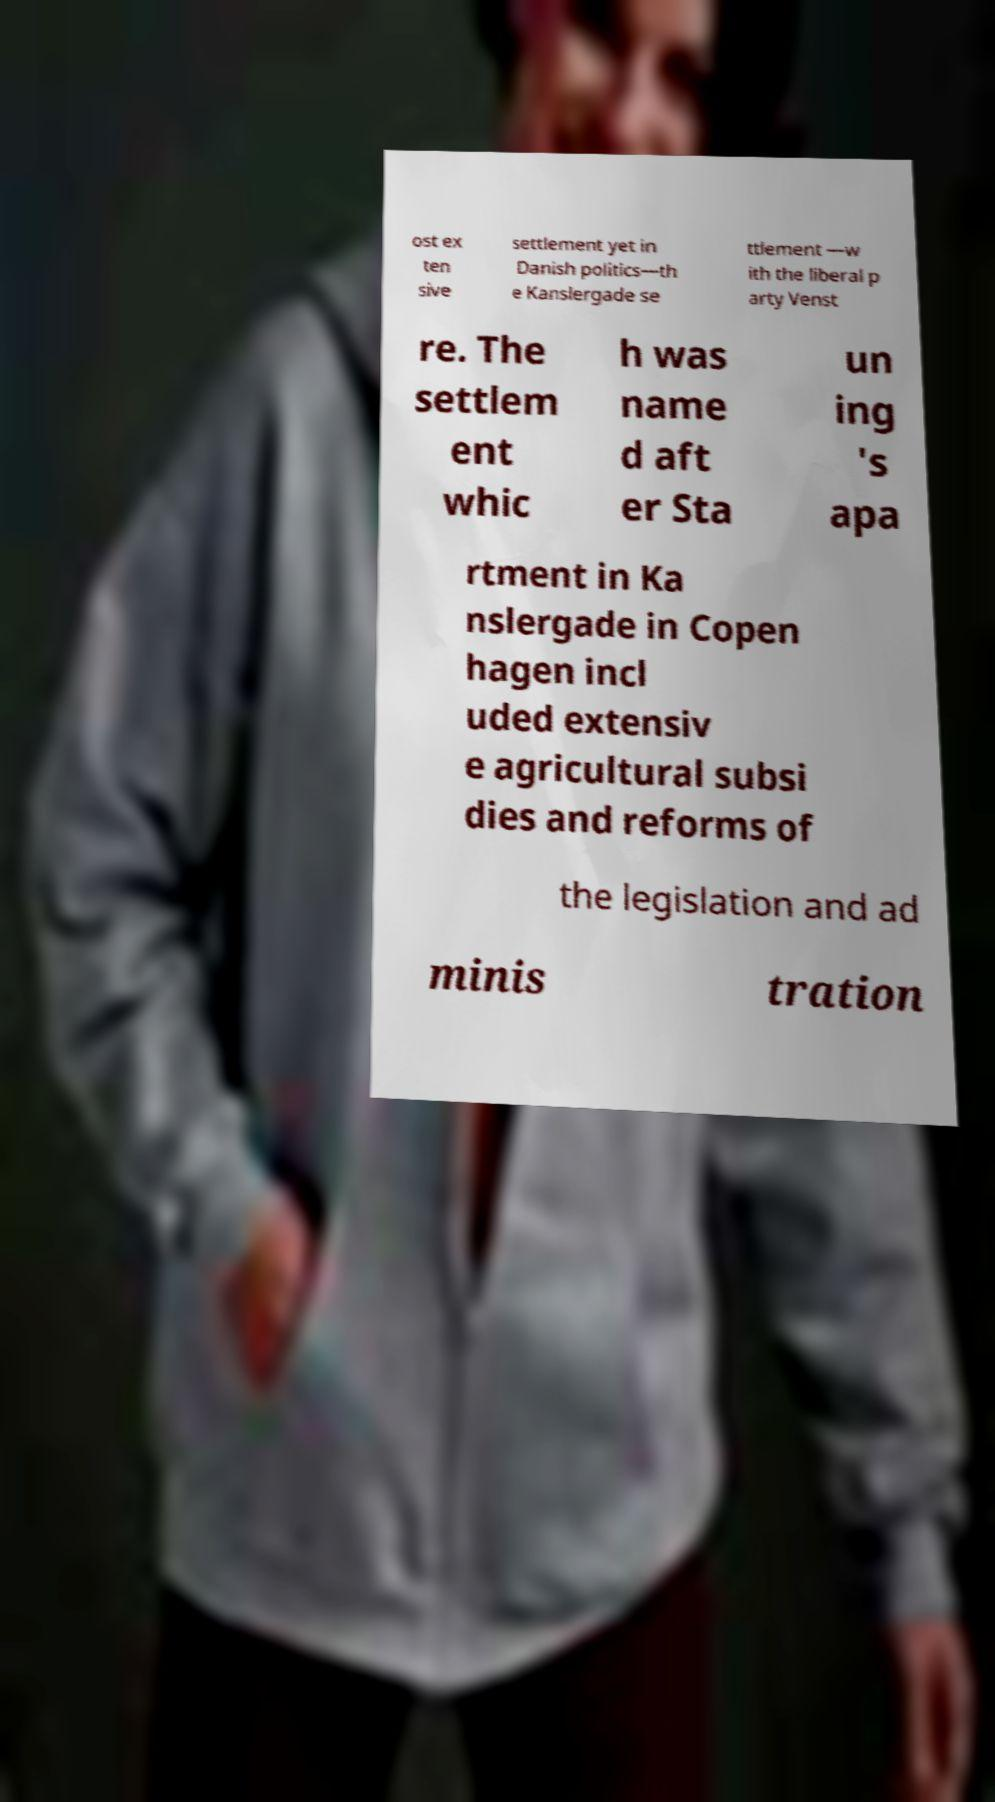Can you accurately transcribe the text from the provided image for me? ost ex ten sive settlement yet in Danish politics—th e Kanslergade se ttlement —w ith the liberal p arty Venst re. The settlem ent whic h was name d aft er Sta un ing 's apa rtment in Ka nslergade in Copen hagen incl uded extensiv e agricultural subsi dies and reforms of the legislation and ad minis tration 